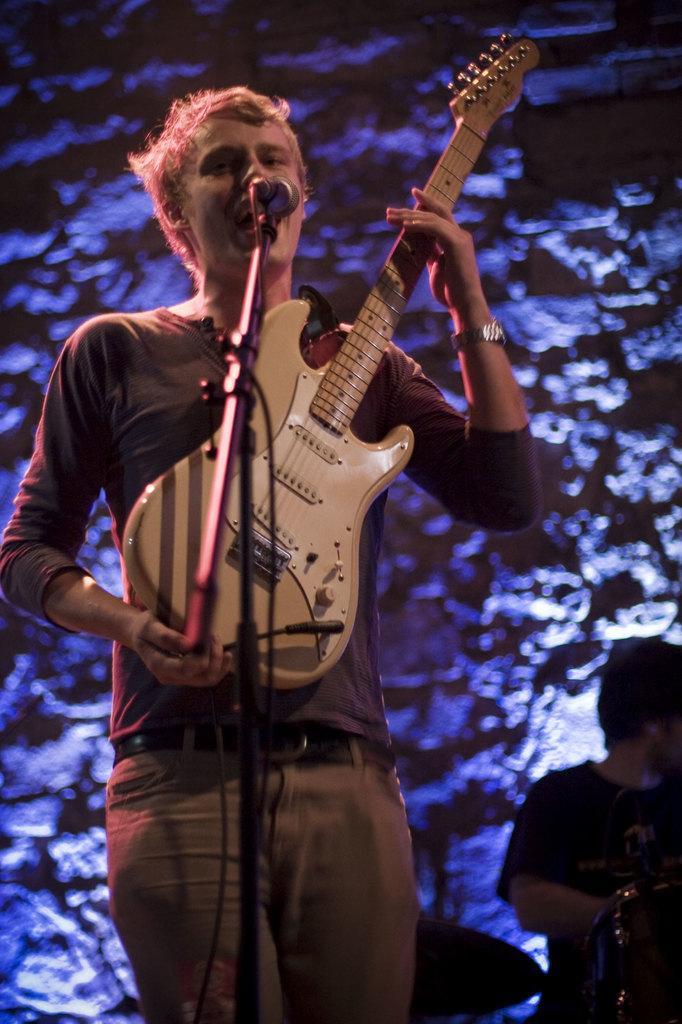Please provide a concise description of this image. In this picture there is a boy who is standing at the left side of the image, by holding the guitar in his hands and there is a mic in front of him there is another boy at the right side of the image, the background color is blue. 